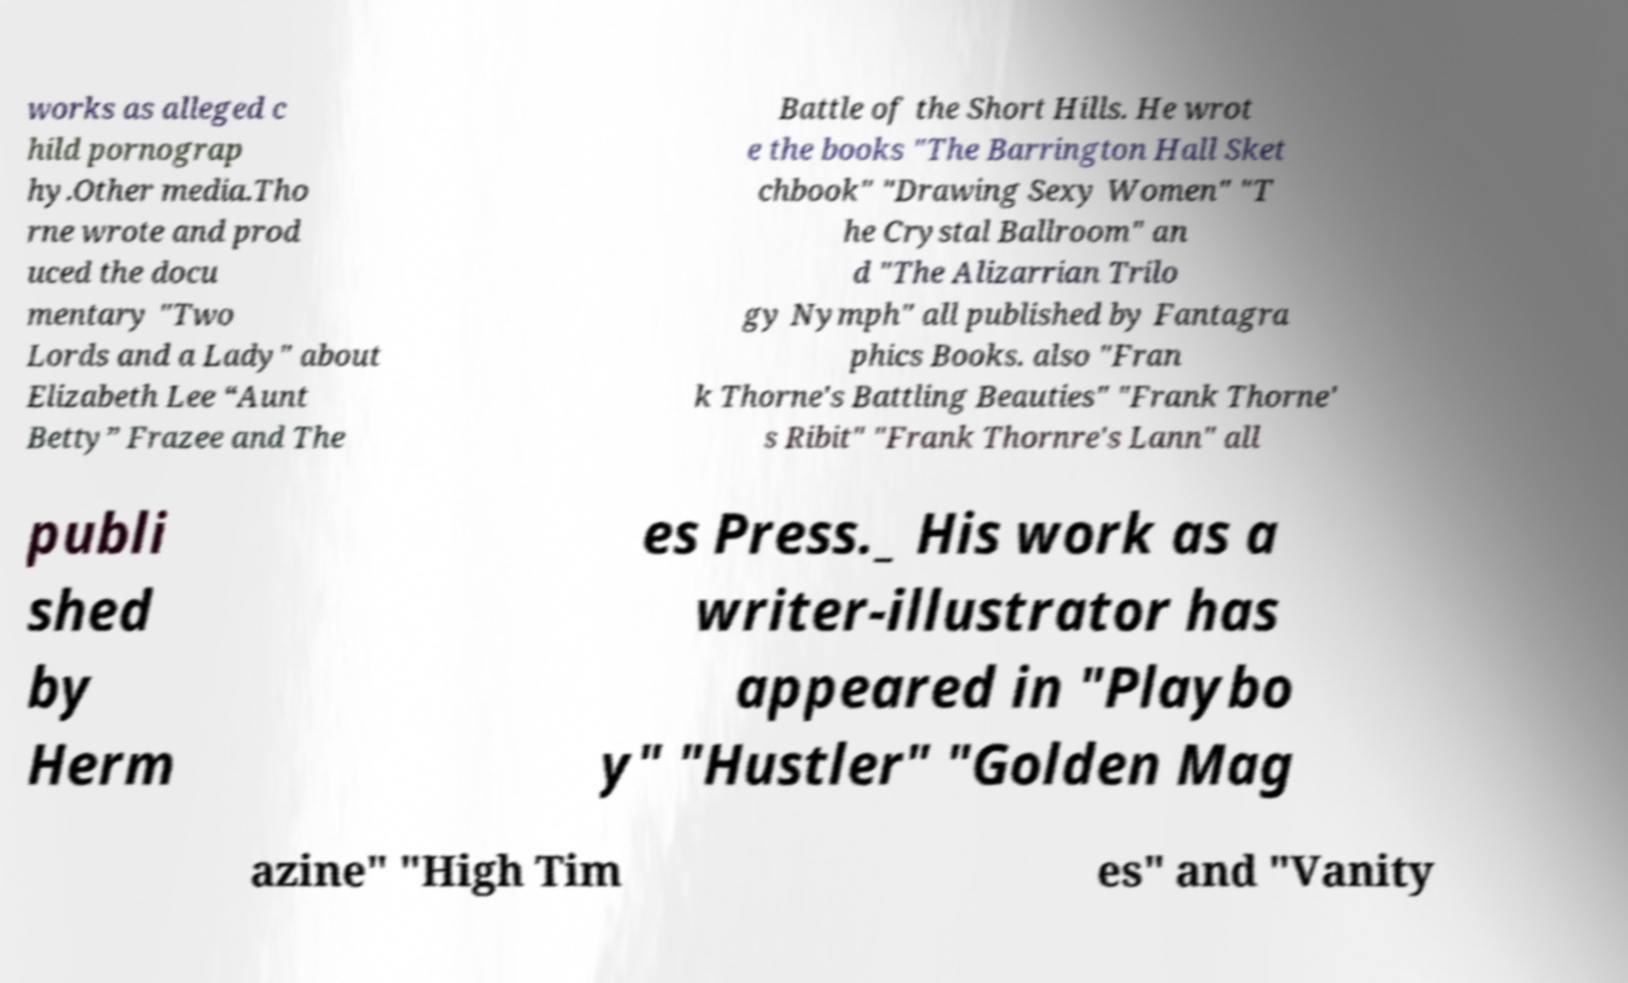For documentation purposes, I need the text within this image transcribed. Could you provide that? works as alleged c hild pornograp hy.Other media.Tho rne wrote and prod uced the docu mentary "Two Lords and a Lady" about Elizabeth Lee “Aunt Betty” Frazee and The Battle of the Short Hills. He wrot e the books "The Barrington Hall Sket chbook" "Drawing Sexy Women" "T he Crystal Ballroom" an d "The Alizarrian Trilo gy Nymph" all published by Fantagra phics Books. also "Fran k Thorne's Battling Beauties" "Frank Thorne' s Ribit" "Frank Thornre's Lann" all publi shed by Herm es Press._ His work as a writer-illustrator has appeared in "Playbo y" "Hustler" "Golden Mag azine" "High Tim es" and "Vanity 